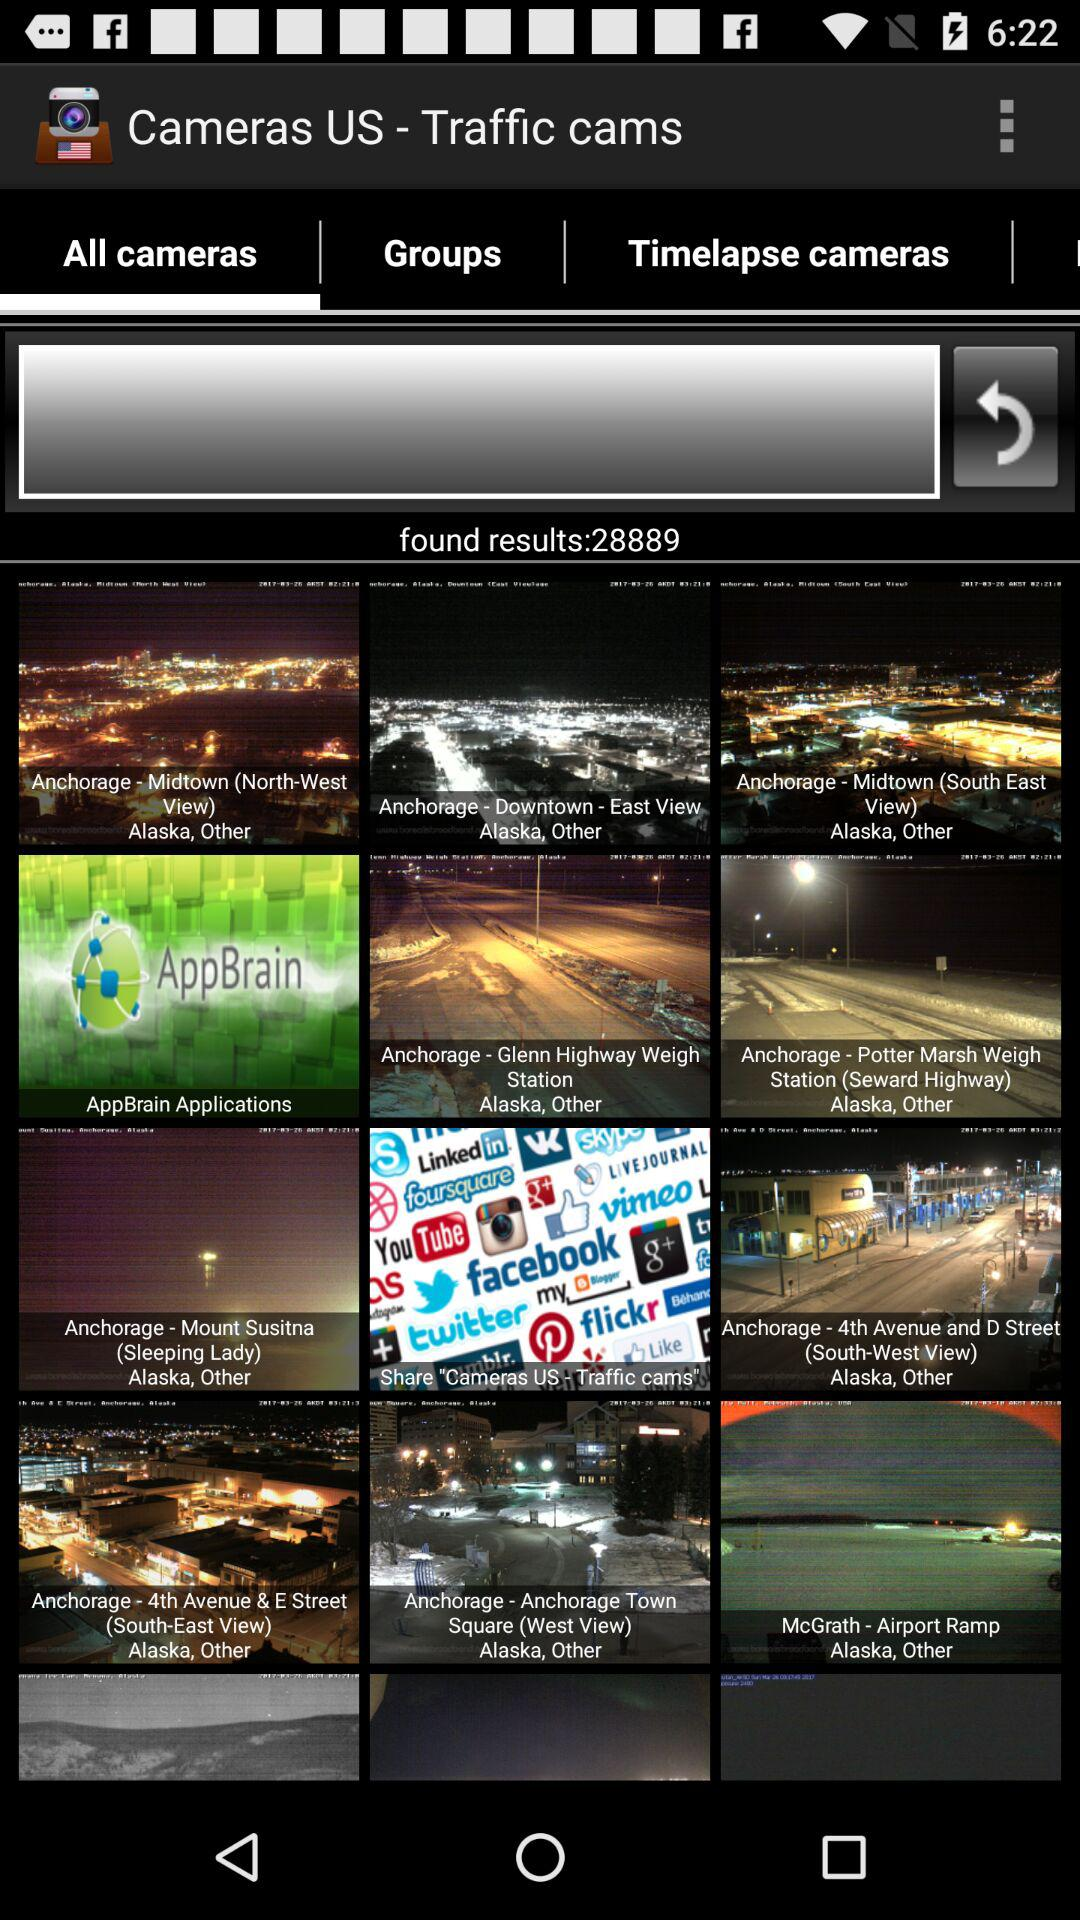How many results are there?
Answer the question using a single word or phrase. 28889 